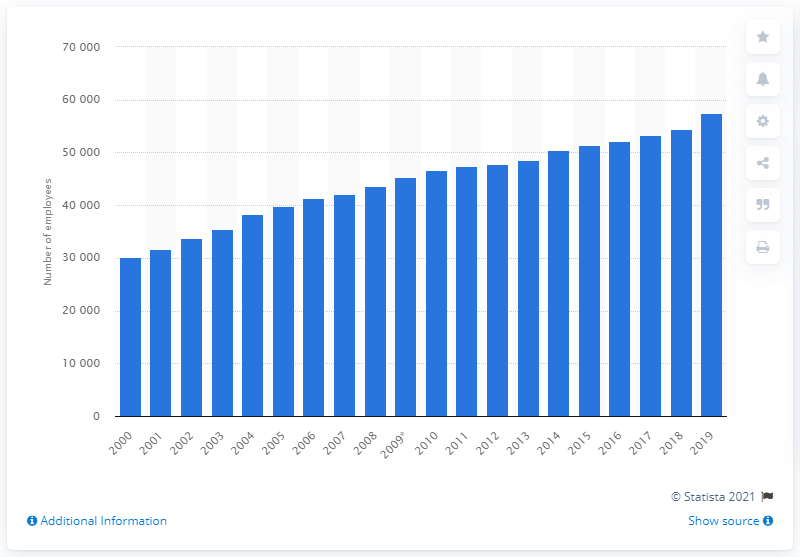Give some essential details in this illustration. In 2000, there were 30,148 specialist surgeons employed in the health sector in the United Kingdom. 